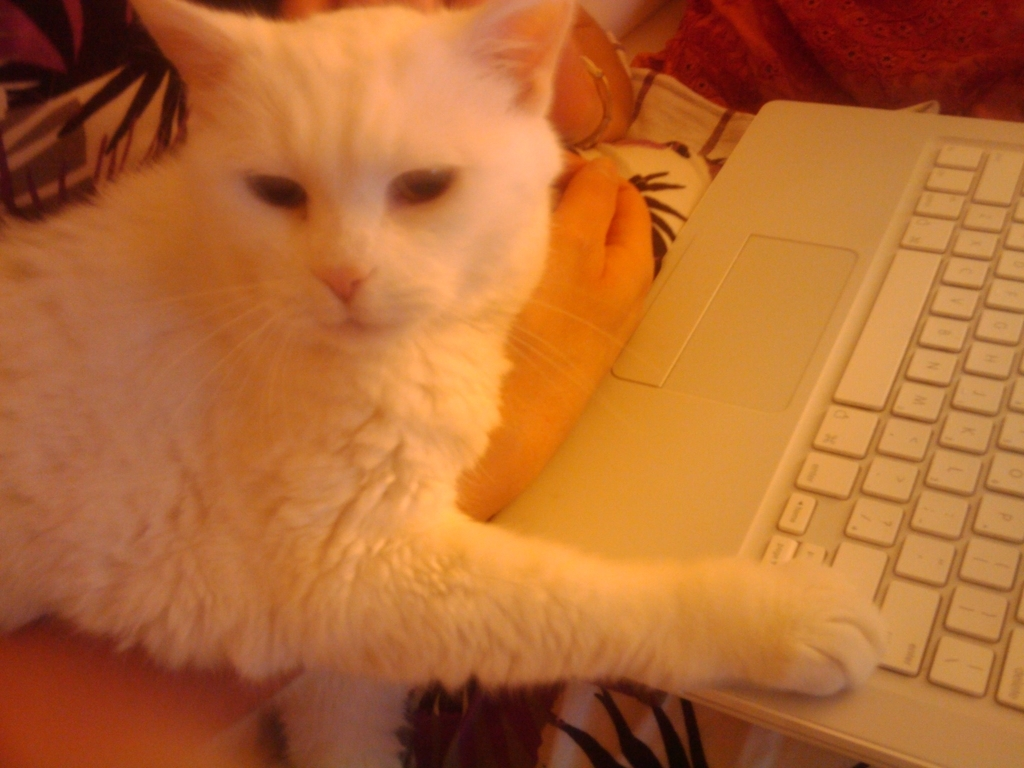What activity does the cat seem to be engaged in? The cat appears to be interrupting someone working on the laptop, which is a common behavior among cats. They often seek attention and interaction by placing themselves in the middle of their owner's activities, in this case, possibly on the keyboard of the laptop. 